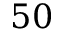Convert formula to latex. <formula><loc_0><loc_0><loc_500><loc_500>5 0</formula> 